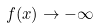<formula> <loc_0><loc_0><loc_500><loc_500>f ( x ) \rightarrow - \infty</formula> 